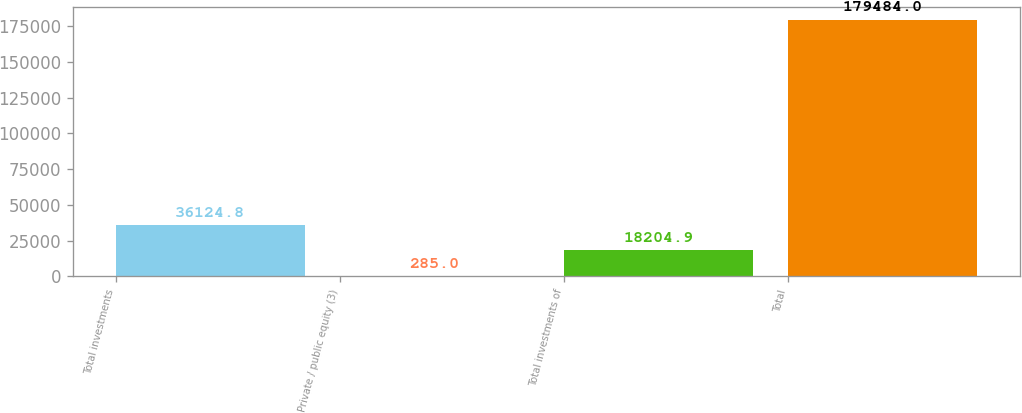Convert chart to OTSL. <chart><loc_0><loc_0><loc_500><loc_500><bar_chart><fcel>Total investments<fcel>Private / public equity (3)<fcel>Total investments of<fcel>Total<nl><fcel>36124.8<fcel>285<fcel>18204.9<fcel>179484<nl></chart> 